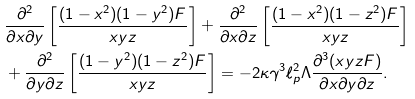Convert formula to latex. <formula><loc_0><loc_0><loc_500><loc_500>& \frac { \partial ^ { 2 } } { \partial x \partial y } \left [ \frac { ( 1 - x ^ { 2 } ) ( 1 - y ^ { 2 } ) F } { x y z } \right ] + \frac { \partial ^ { 2 } } { \partial x \partial z } \left [ \frac { ( 1 - x ^ { 2 } ) ( 1 - z ^ { 2 } ) F } { x y z } \right ] \\ & + \frac { \partial ^ { 2 } } { \partial y \partial z } \left [ \frac { ( 1 - y ^ { 2 } ) ( 1 - z ^ { 2 } ) F } { x y z } \right ] = - 2 \kappa \gamma ^ { 3 } \ell ^ { 2 } _ { p } \Lambda \frac { \partial ^ { 3 } ( x y z F ) } { \partial x \partial y \partial z } .</formula> 